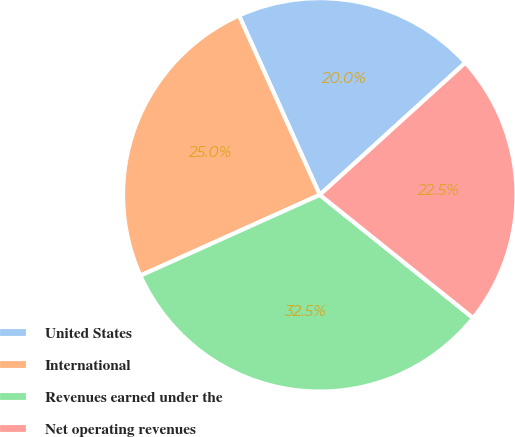<chart> <loc_0><loc_0><loc_500><loc_500><pie_chart><fcel>United States<fcel>International<fcel>Revenues earned under the<fcel>Net operating revenues<nl><fcel>20.0%<fcel>25.0%<fcel>32.5%<fcel>22.5%<nl></chart> 